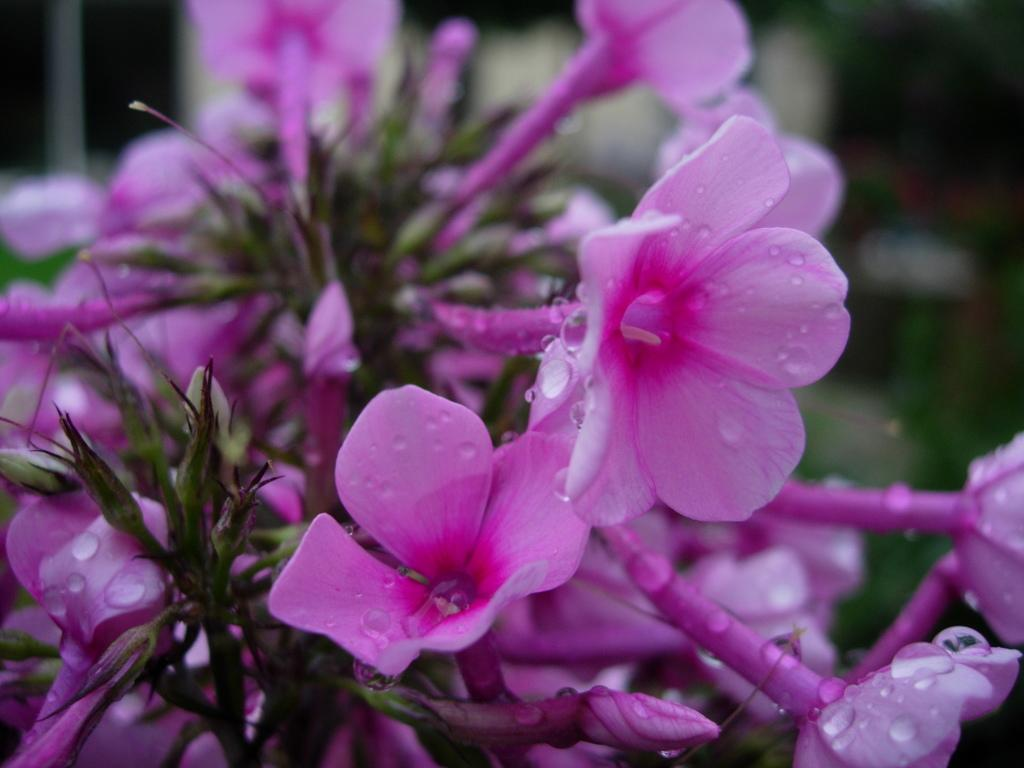What type of objects are present in the image? There are flowers in the image. What color are the flowers? The flowers are pink in color. Can you describe the background of the image? The background of the image is blurry. What type of friction can be observed between the flowers in the image? There is no friction present between the flowers in the image, as they are not interacting with each other or any other objects. 